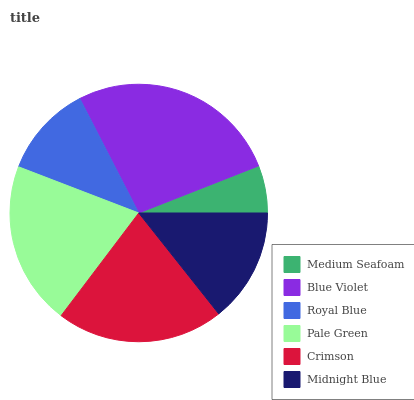Is Medium Seafoam the minimum?
Answer yes or no. Yes. Is Blue Violet the maximum?
Answer yes or no. Yes. Is Royal Blue the minimum?
Answer yes or no. No. Is Royal Blue the maximum?
Answer yes or no. No. Is Blue Violet greater than Royal Blue?
Answer yes or no. Yes. Is Royal Blue less than Blue Violet?
Answer yes or no. Yes. Is Royal Blue greater than Blue Violet?
Answer yes or no. No. Is Blue Violet less than Royal Blue?
Answer yes or no. No. Is Pale Green the high median?
Answer yes or no. Yes. Is Midnight Blue the low median?
Answer yes or no. Yes. Is Crimson the high median?
Answer yes or no. No. Is Crimson the low median?
Answer yes or no. No. 